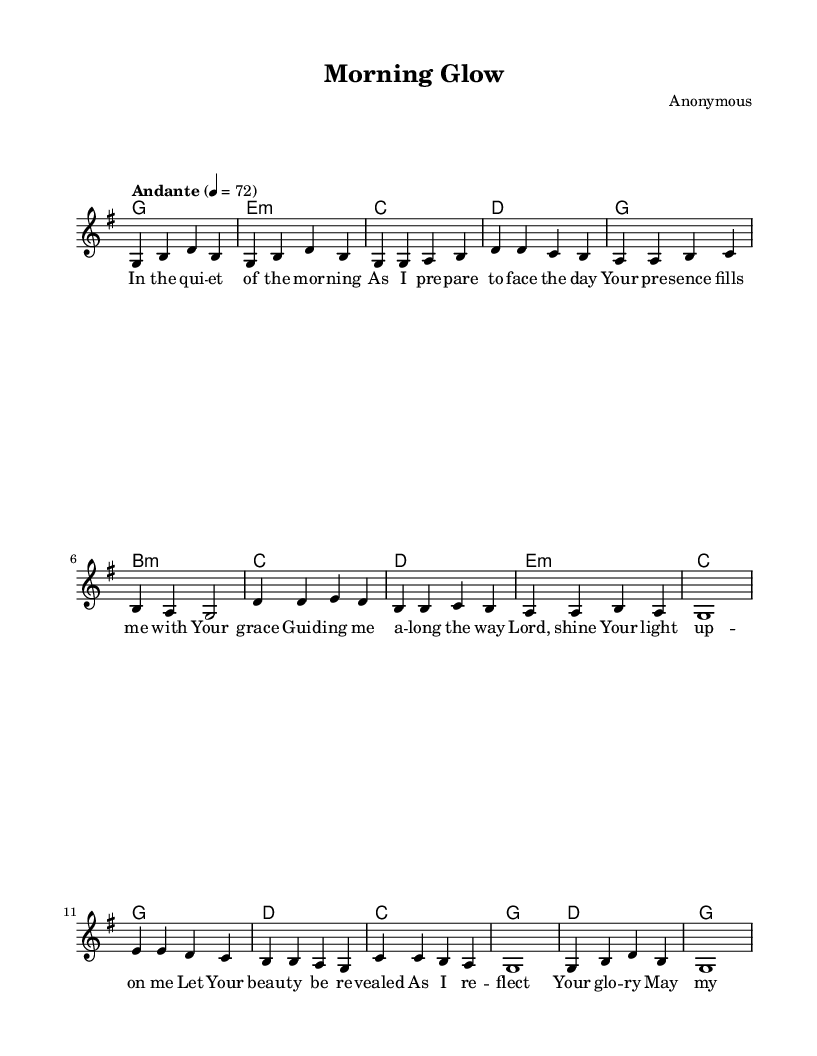What is the key signature of this music? The key signature is G major, which has one sharp. This can be identified from the notation in the global section of the code where it specifies `\key g \major`.
Answer: G major What is the time signature of this music? The time signature is 4/4, indicated in the global section by `\time 4/4`. This means there are four beats in each measure, and the quarter note gets one beat.
Answer: 4/4 What is the tempo marking of this piece? The tempo marking is "Andante," indicated by the line `\tempo "Andante" 4 = 72`. "Andante" generally means a moderately slow tempo, and the number 72 refers to the beats per minute.
Answer: Andante How many measures are in the chorus section? The chorus section consists of four measures. This can be determined by counting the measures in the `chorus` section in the provided melody data.
Answer: Four What is the first lyric line of the verse? The first lyric line in the verse is "In the quiet of the morning." This is found right under the `verseOne` lyrics section, where each line of lyrics corresponds to the melody.
Answer: In the quiet of the morning What do the lyrics in the chorus emphasize? The lyrics in the chorus emphasize confidence and beauty, as they speak of reflecting glory and having confidence sealed through divine light. This thematic content can be inferred from the words used in the `chorus` lyric section.
Answer: Confidence and beauty What is the purpose of the key change in religious music like this piece? The key change is often meant to create emotional depth and spiritual elevation, allowing the worshiper to feel a stronger connection to the divine. In this music, the themes and harmonies support this worshipful atmosphere, characteristic of religious compositions.
Answer: Emotional depth 